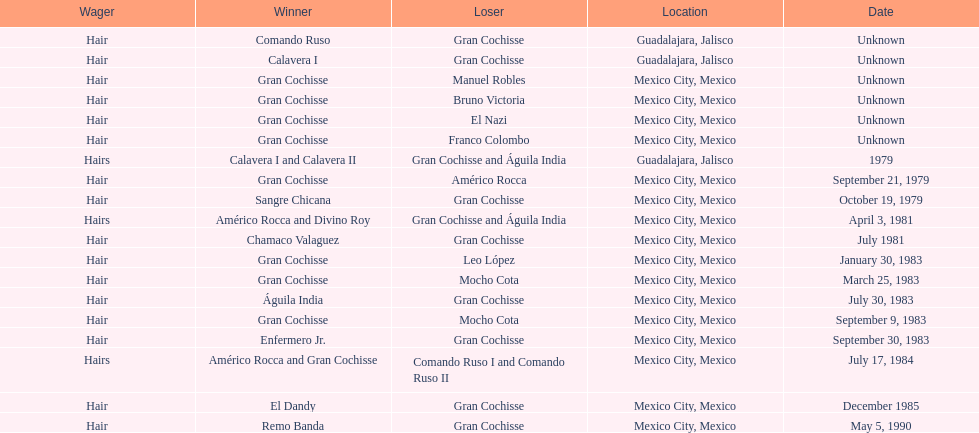How many games more than chamaco valaguez did sangre chicana win? 0. 